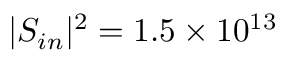<formula> <loc_0><loc_0><loc_500><loc_500>| S _ { i n } | ^ { 2 } = 1 . 5 \times 1 0 ^ { 1 3 }</formula> 